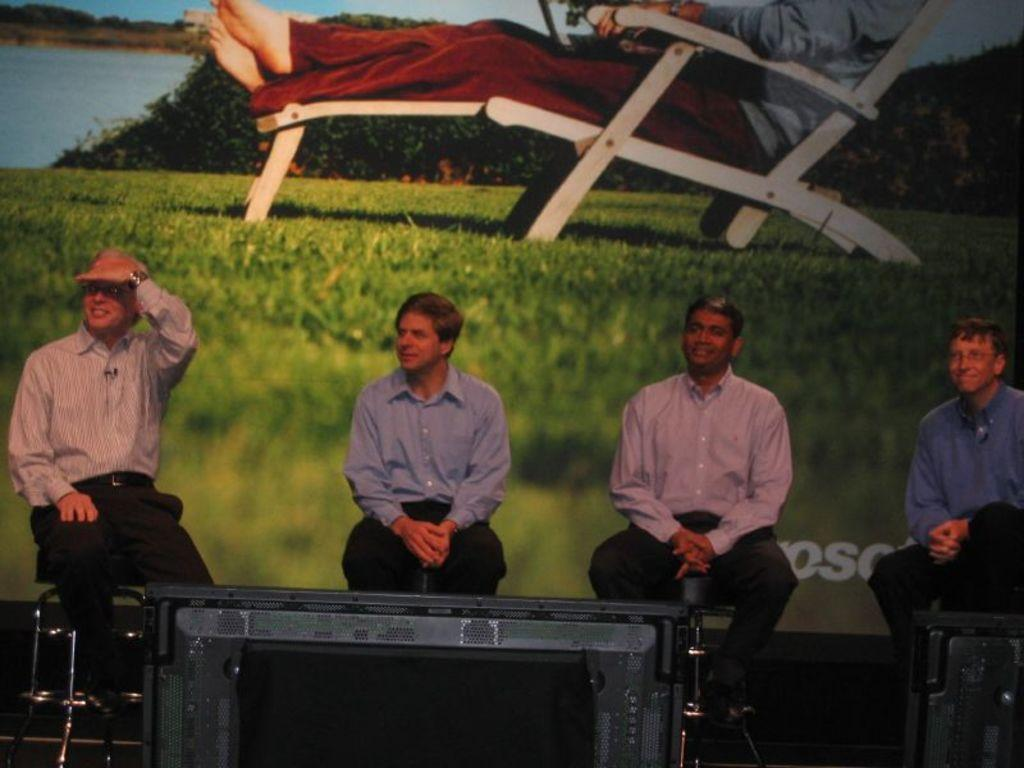How many people are present in the image? There are four people sitting in the image. What is the facial expression of the people in the image? The people are smiling. What type of clothing are the people wearing? The people are wearing shirts. What can be seen in the background of the image? There is a screen and a person sitting on a chair in the background of the image. What type of popcorn is being served during the expansion of interest in the image? There is no popcorn or expansion of interest present in the image. 